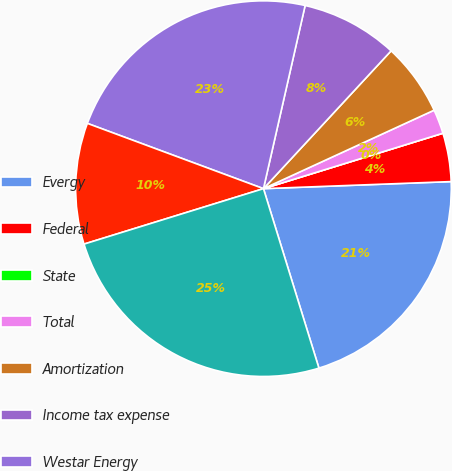Convert chart. <chart><loc_0><loc_0><loc_500><loc_500><pie_chart><fcel>Evergy<fcel>Federal<fcel>State<fcel>Total<fcel>Amortization<fcel>Income tax expense<fcel>Westar Energy<fcel>Income tax expense (benefit)<fcel>KCP&L<nl><fcel>20.83%<fcel>4.17%<fcel>0.0%<fcel>2.09%<fcel>6.25%<fcel>8.33%<fcel>22.91%<fcel>10.42%<fcel>25.0%<nl></chart> 